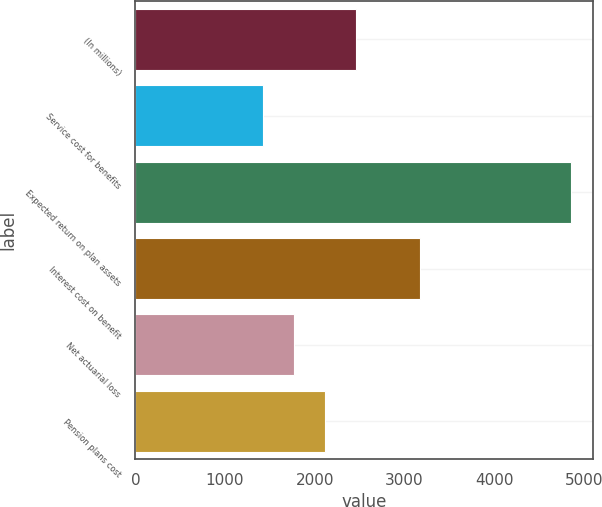Convert chart. <chart><loc_0><loc_0><loc_500><loc_500><bar_chart><fcel>(In millions)<fcel>Service cost for benefits<fcel>Expected return on plan assets<fcel>Interest cost on benefit<fcel>Net actuarial loss<fcel>Pension plans cost<nl><fcel>2455.3<fcel>1426<fcel>4857<fcel>3179<fcel>1769.1<fcel>2112.2<nl></chart> 